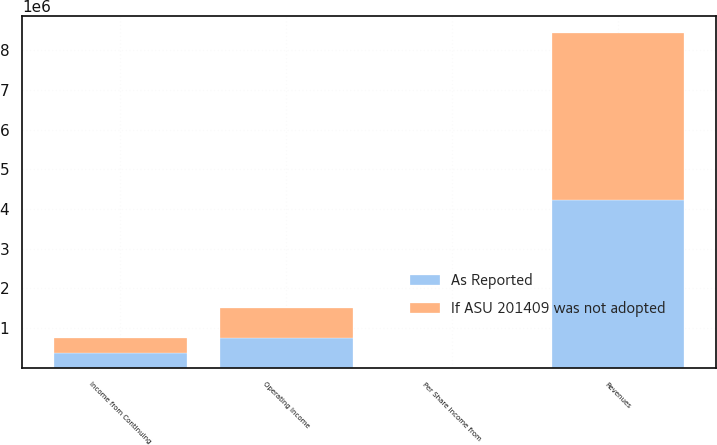<chart> <loc_0><loc_0><loc_500><loc_500><stacked_bar_chart><ecel><fcel>Revenues<fcel>Operating Income<fcel>Income from Continuing<fcel>Per Share Income from<nl><fcel>As Reported<fcel>4.22576e+06<fcel>755508<fcel>376976<fcel>1.31<nl><fcel>If ASU 201409 was not adopted<fcel>4.21966e+06<fcel>751648<fcel>373113<fcel>1.3<nl></chart> 